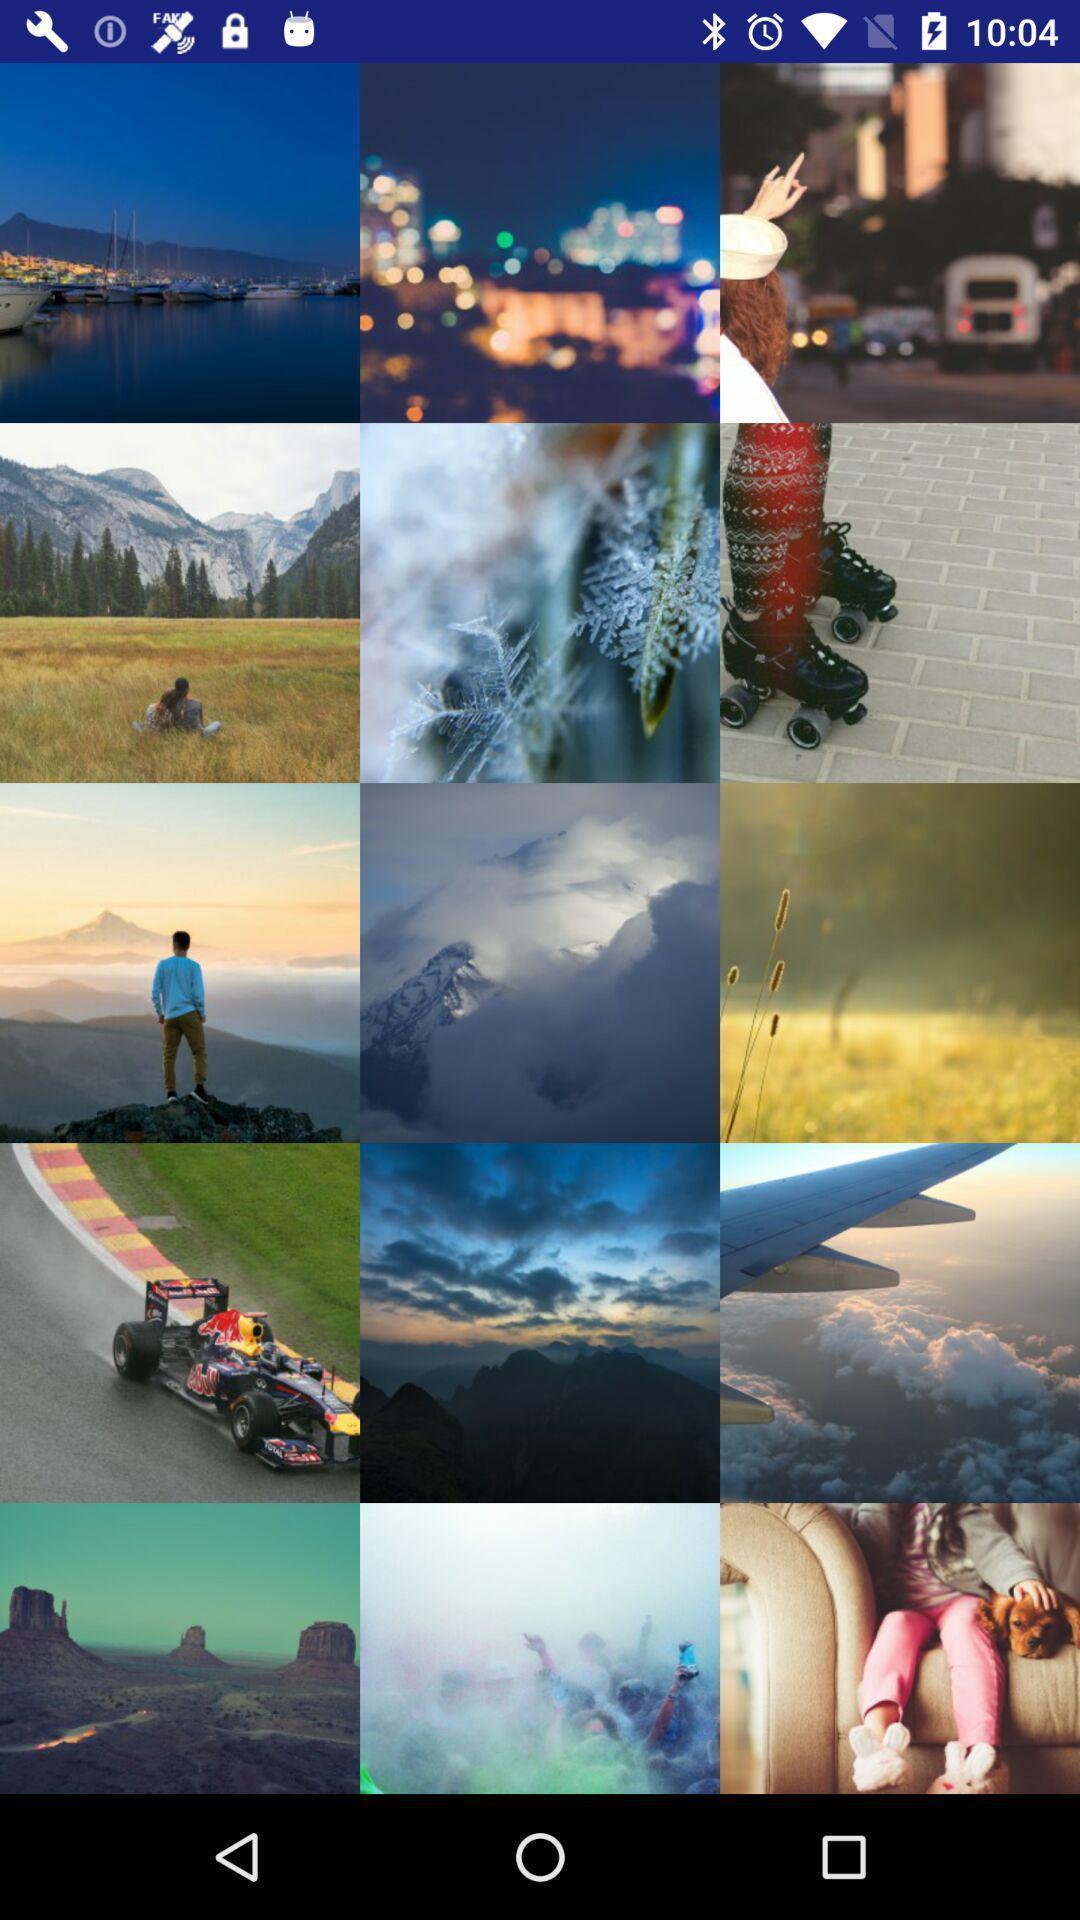What can you discern from this picture? Screen displaying list of photos. 